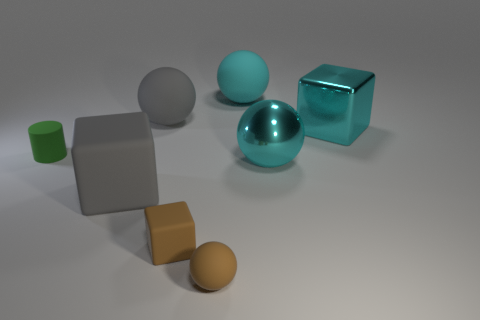Subtract all gray blocks. How many blocks are left? 2 Subtract all purple cylinders. How many cyan spheres are left? 2 Subtract 1 blocks. How many blocks are left? 2 Subtract all gray spheres. How many spheres are left? 3 Add 1 brown matte balls. How many objects exist? 9 Subtract all cylinders. How many objects are left? 7 Subtract all blue balls. Subtract all cyan cylinders. How many balls are left? 4 Add 3 metallic things. How many metallic things exist? 5 Subtract 0 purple spheres. How many objects are left? 8 Subtract all big rubber blocks. Subtract all big spheres. How many objects are left? 4 